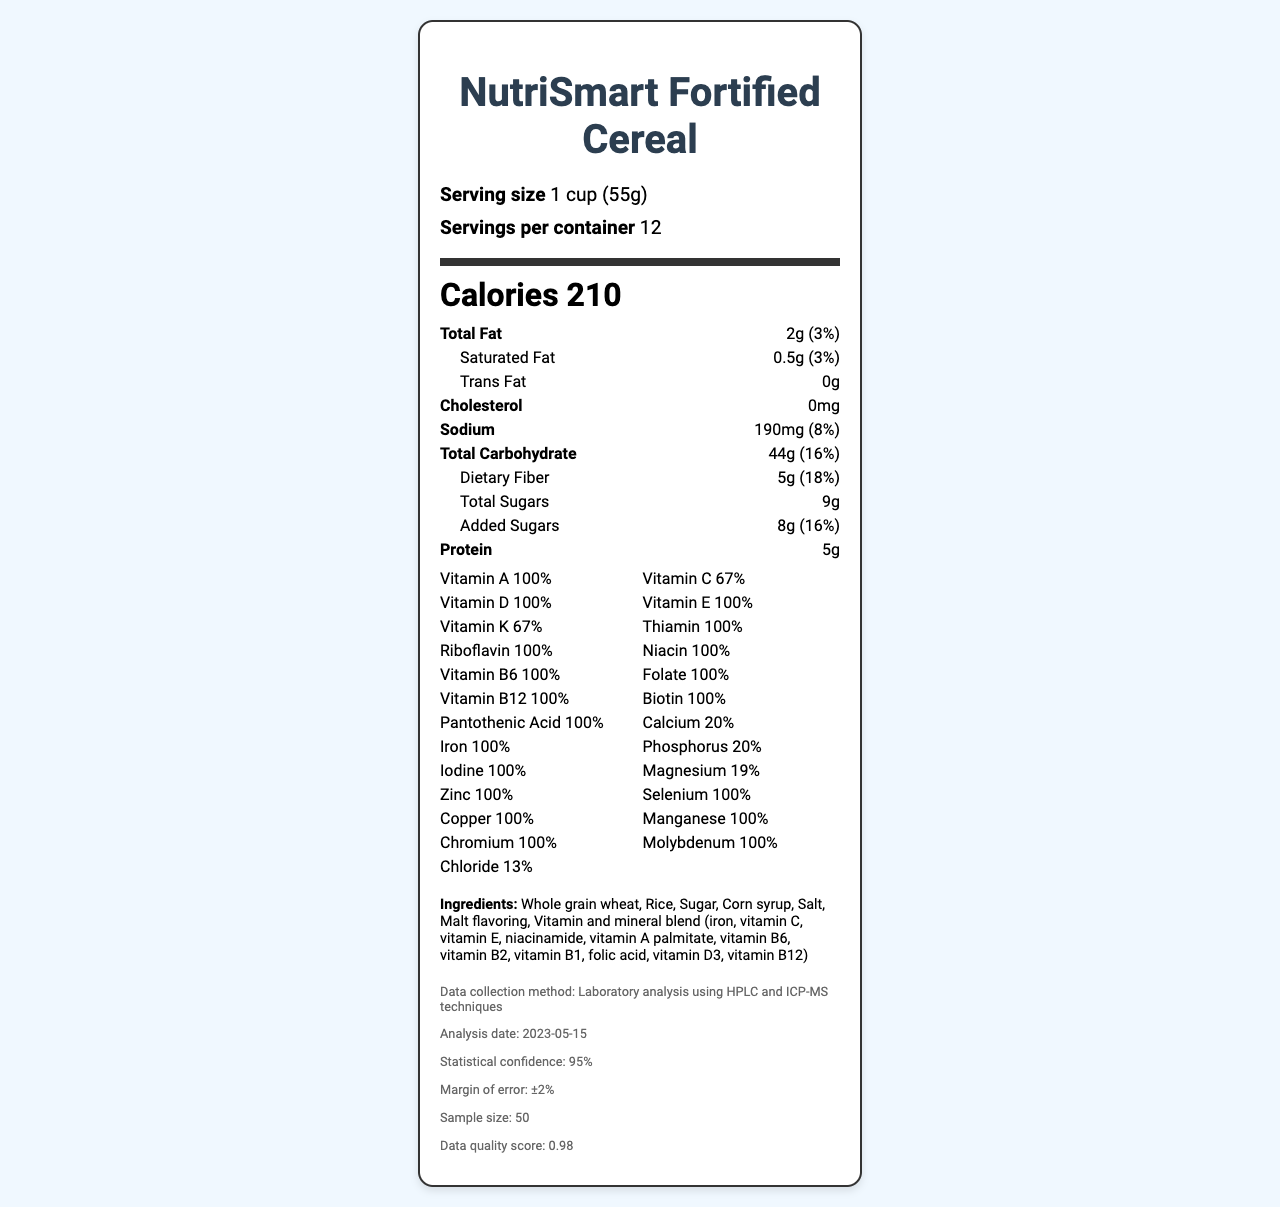what is the serving size of NutriSmart Fortified Cereal? The serving size is explicitly mentioned at the beginning of the Nutrition Facts Label.
Answer: 1 cup (55g) how many servings are there per container? The label specifies that there are 12 servings per container.
Answer: 12 what is the total amount of dietary fiber per serving? The amount of dietary fiber per serving is listed as 5g in the nutrient section of the label.
Answer: 5g how much sodium is in one serving, and what is its daily value percentage? The sodium content per serving is given as 190mg, and it corresponds to 8% of the daily value.
Answer: 190mg, 8% name three vitamins present in NutriSmart Fortified Cereal that provide 100% of the daily value The listed vitamins with 100% daily value include Vitamin A, Vitamin D, and Iron among others.
Answer: Vitamin A, Vitamin D, Iron does NutriSmart Fortified Cereal contain any cholesterol? The Nutrition Facts Label states that it contains 0mg of cholesterol.
Answer: No how many grams of protein are there in one serving? Each serving contains 5g of protein as indicated on the label.
Answer: 5g how many grams of total carbohydrates are there per serving? The amount of total carbohydrates per serving is provided as 44g.
Answer: 44g what is the daily value percentage for total sugars in one serving? The daily value percentage for total sugars is not provided; only the amount (9g) is listed.
Answer: Not listed which of the following ingredients is first listed on the ingredient list? A. Rice B. Sugar C. Whole grain wheat The first ingredient listed is "Whole grain wheat".
Answer: C what percentage of the daily value of Vitamin C does one serving provide? A. 50% B. 67% C. 80% D. 90% One serving provides 67% of the daily value of Vitamin C, as stated on the nutrition label.
Answer: B is the cereal manufactured by HealthyChoice Foods Inc.? The manufacturer's name is listed as HealthyChoice Foods Inc. in the document.
Answer: Yes summarize the key nutritional information and other important details provided in the Nutrition Facts Label. The summary includes an overview of the primary nutritional values, ingredient highlights, manufacturer information, and details about the data collection method noted in the document.
Answer: The NutriSmart Fortified Cereal has a serving size of 1 cup (55g) with 12 servings per container. It includes 210 calories per serving, 2g total fat, 44g total carbohydrates, 5g dietary fiber, 9g total sugars (with 8g added sugars), and 5g protein. The cereal is fortified with a variety of vitamins and minerals, offering 100% daily value for several key nutrients such as Iron, Vitamin A, and Vitamin D. The ingredient list includes whole grain wheat, rice, sugar, and a blend of vitamins and minerals. The product contains wheat and may contain soy and tree nuts. It is manufactured by HealthyChoice Foods Inc. The nutritional analysis was performed using HPLC and ICP-MS techniques with statistical results noted on the label. how much Calcium is provided per serving and what is its daily value percentage? The label states that there are 260mg of Calcium per serving, which is 20% of the daily value.
Answer: 260mg, 20% which item has a higher daily value percentage: Magnesium or Chloride? Chloride has a daily value of 13%, while Magnesium has a daily value of 19%.
Answer: Chloride what is the margin of error for the data collected? The margin of error indicated in the data collection information is ±2%.
Answer: ±2% what is the sample size used for the nutritional analysis? The nutritional analysis was conducted on a sample size of 50.
Answer: 50 has the data collection method been provided in the document? The document mentions that the data was collected using laboratory analysis involving HPLC and ICP-MS techniques.
Answer: Yes what is the total amount of added sugars and the respective daily value percentage? The label indicates there are 8g of added sugars, which is 16% of the daily value.
Answer: 8g, 16% 